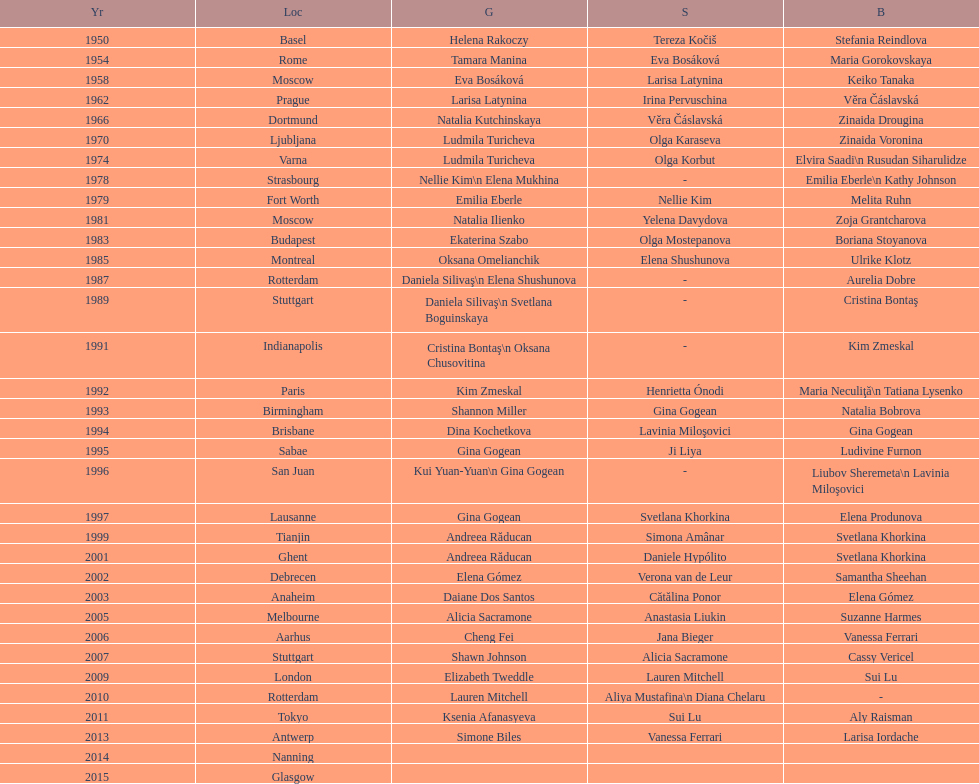How long is the time between the times the championship was held in moscow? 23 years. I'm looking to parse the entire table for insights. Could you assist me with that? {'header': ['Yr', 'Loc', 'G', 'S', 'B'], 'rows': [['1950', 'Basel', 'Helena Rakoczy', 'Tereza Kočiš', 'Stefania Reindlova'], ['1954', 'Rome', 'Tamara Manina', 'Eva Bosáková', 'Maria Gorokovskaya'], ['1958', 'Moscow', 'Eva Bosáková', 'Larisa Latynina', 'Keiko Tanaka'], ['1962', 'Prague', 'Larisa Latynina', 'Irina Pervuschina', 'Věra Čáslavská'], ['1966', 'Dortmund', 'Natalia Kutchinskaya', 'Věra Čáslavská', 'Zinaida Drougina'], ['1970', 'Ljubljana', 'Ludmila Turicheva', 'Olga Karaseva', 'Zinaida Voronina'], ['1974', 'Varna', 'Ludmila Turicheva', 'Olga Korbut', 'Elvira Saadi\\n Rusudan Siharulidze'], ['1978', 'Strasbourg', 'Nellie Kim\\n Elena Mukhina', '-', 'Emilia Eberle\\n Kathy Johnson'], ['1979', 'Fort Worth', 'Emilia Eberle', 'Nellie Kim', 'Melita Ruhn'], ['1981', 'Moscow', 'Natalia Ilienko', 'Yelena Davydova', 'Zoja Grantcharova'], ['1983', 'Budapest', 'Ekaterina Szabo', 'Olga Mostepanova', 'Boriana Stoyanova'], ['1985', 'Montreal', 'Oksana Omelianchik', 'Elena Shushunova', 'Ulrike Klotz'], ['1987', 'Rotterdam', 'Daniela Silivaş\\n Elena Shushunova', '-', 'Aurelia Dobre'], ['1989', 'Stuttgart', 'Daniela Silivaş\\n Svetlana Boguinskaya', '-', 'Cristina Bontaş'], ['1991', 'Indianapolis', 'Cristina Bontaş\\n Oksana Chusovitina', '-', 'Kim Zmeskal'], ['1992', 'Paris', 'Kim Zmeskal', 'Henrietta Ónodi', 'Maria Neculiţă\\n Tatiana Lysenko'], ['1993', 'Birmingham', 'Shannon Miller', 'Gina Gogean', 'Natalia Bobrova'], ['1994', 'Brisbane', 'Dina Kochetkova', 'Lavinia Miloşovici', 'Gina Gogean'], ['1995', 'Sabae', 'Gina Gogean', 'Ji Liya', 'Ludivine Furnon'], ['1996', 'San Juan', 'Kui Yuan-Yuan\\n Gina Gogean', '-', 'Liubov Sheremeta\\n Lavinia Miloşovici'], ['1997', 'Lausanne', 'Gina Gogean', 'Svetlana Khorkina', 'Elena Produnova'], ['1999', 'Tianjin', 'Andreea Răducan', 'Simona Amânar', 'Svetlana Khorkina'], ['2001', 'Ghent', 'Andreea Răducan', 'Daniele Hypólito', 'Svetlana Khorkina'], ['2002', 'Debrecen', 'Elena Gómez', 'Verona van de Leur', 'Samantha Sheehan'], ['2003', 'Anaheim', 'Daiane Dos Santos', 'Cătălina Ponor', 'Elena Gómez'], ['2005', 'Melbourne', 'Alicia Sacramone', 'Anastasia Liukin', 'Suzanne Harmes'], ['2006', 'Aarhus', 'Cheng Fei', 'Jana Bieger', 'Vanessa Ferrari'], ['2007', 'Stuttgart', 'Shawn Johnson', 'Alicia Sacramone', 'Cassy Vericel'], ['2009', 'London', 'Elizabeth Tweddle', 'Lauren Mitchell', 'Sui Lu'], ['2010', 'Rotterdam', 'Lauren Mitchell', 'Aliya Mustafina\\n Diana Chelaru', '-'], ['2011', 'Tokyo', 'Ksenia Afanasyeva', 'Sui Lu', 'Aly Raisman'], ['2013', 'Antwerp', 'Simone Biles', 'Vanessa Ferrari', 'Larisa Iordache'], ['2014', 'Nanning', '', '', ''], ['2015', 'Glasgow', '', '', '']]} 